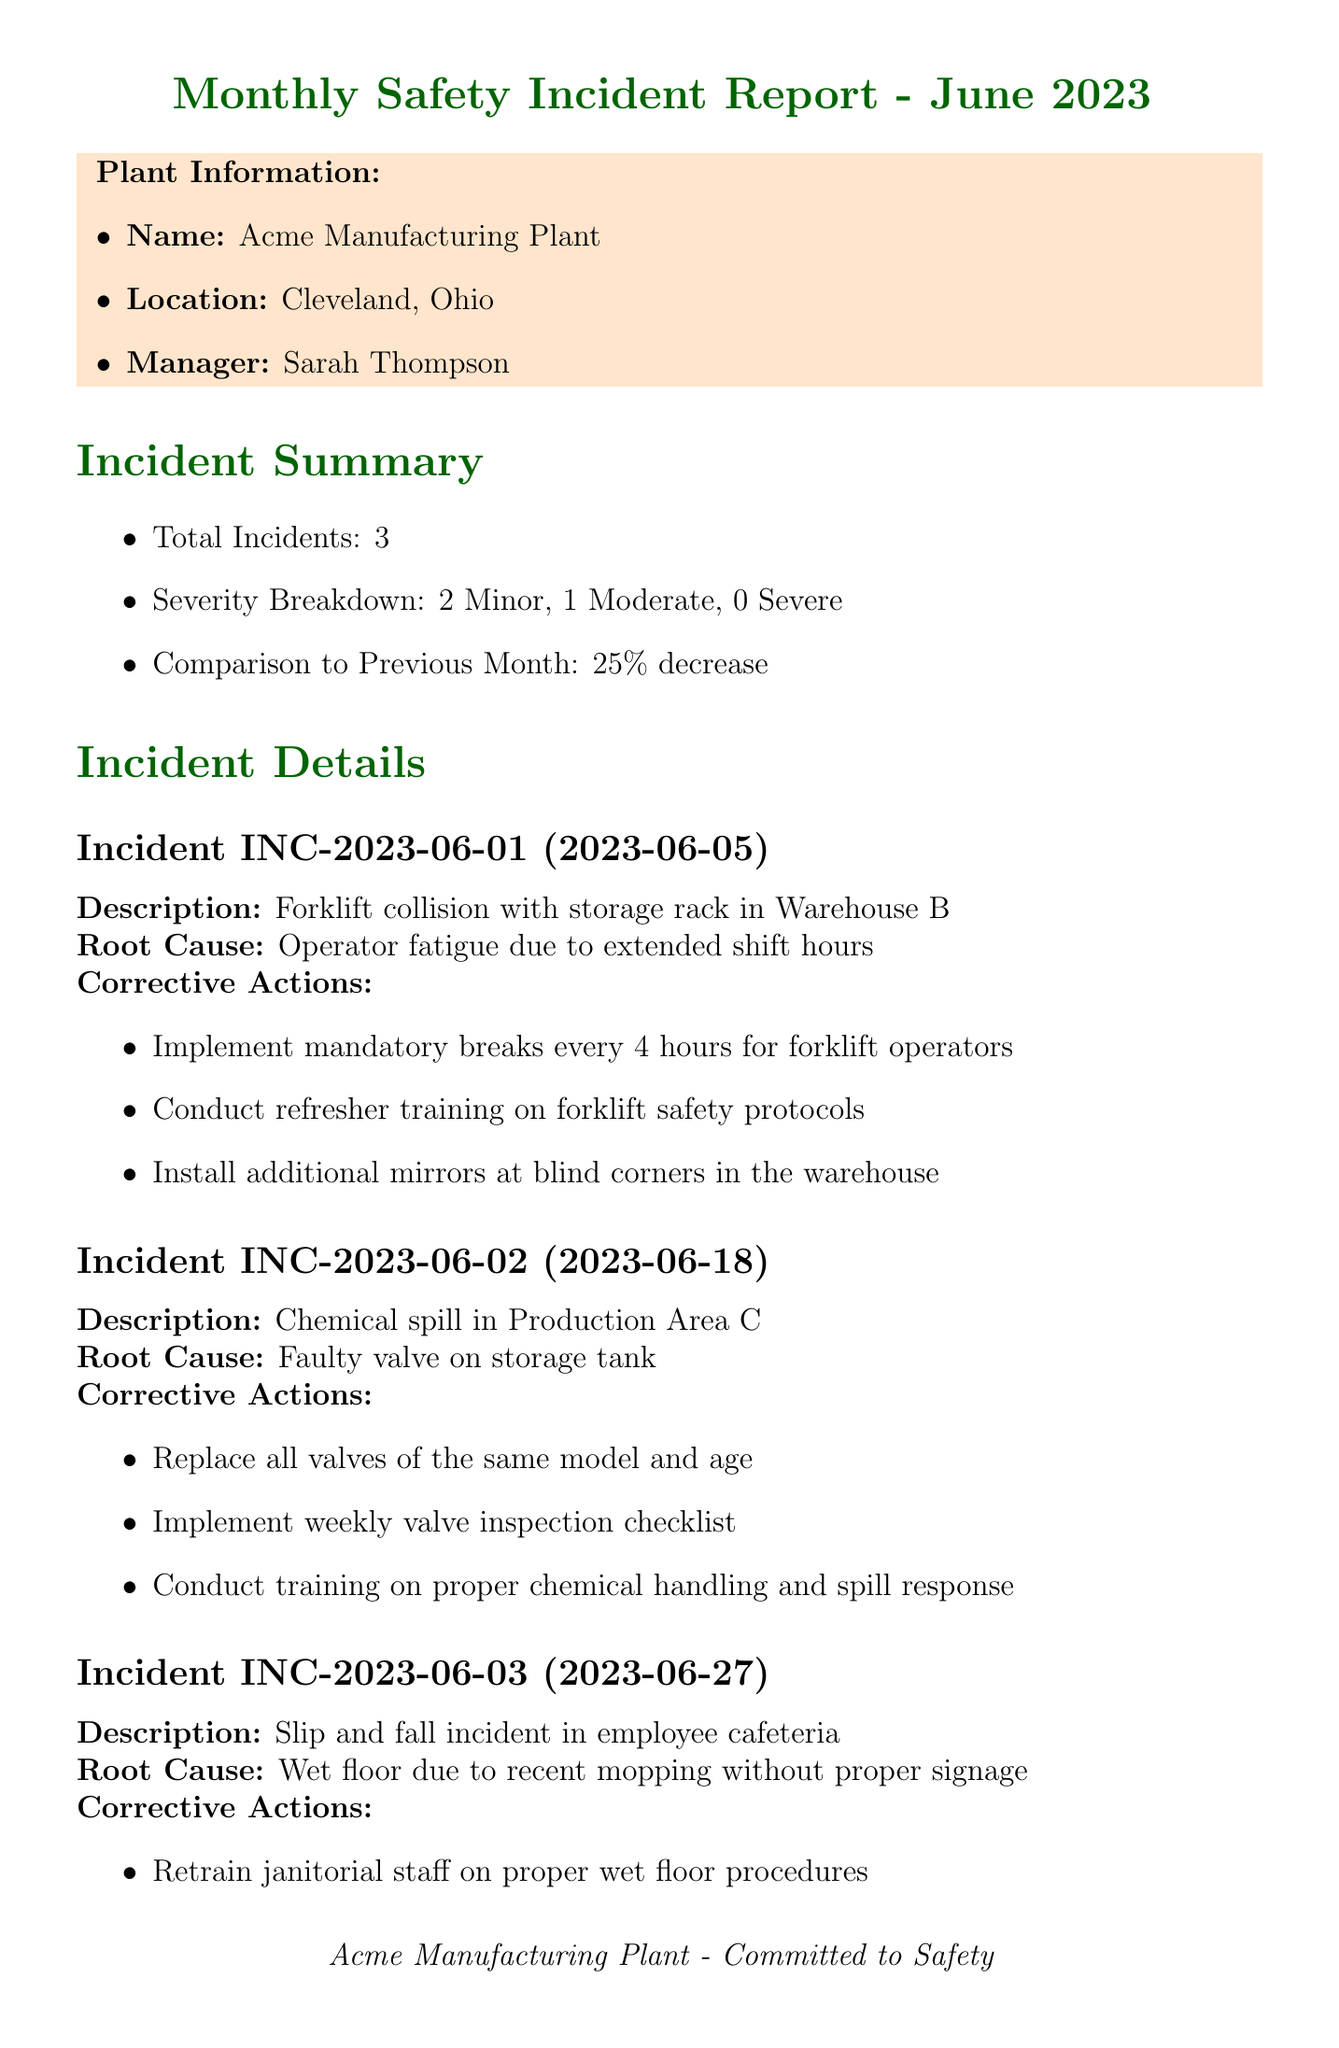What is the total number of incidents reported in June 2023? The total number of incidents in June 2023 is specified in the incident summary section of the document.
Answer: 3 What was the date of the forklift collision incident? The date of the forklift collision incident is listed under the incident details for that specific incident.
Answer: 2023-06-05 Which area had a chemical spill incident? The location of the chemical spill incident is provided in the description of that incident.
Answer: Production Area C What is one corrective action for the slip and fall incident? One of the corrective actions for the slip and fall incident can be found in the list of actions taken in the incident details.
Answer: Retrain janitorial staff on proper wet floor procedures What is the implementation date for the PPE upgrade initiative? The implementation date for the PPE upgrade can be found in the safety initiatives section of the document.
Answer: 2023-08-15 How many minor incidents were reported in June 2023? The severity breakdown in the incident summary provides the count of minor incidents.
Answer: 2 What feedback was received from the Anonymous Suggestion Box? The feedback source and details are listed in the employee feedback section.
Answer: Request for more frequent safety drills What is one of the focus areas mentioned in the conclusion? Focus areas are listed in the conclusion section of the document, which summarizes key improvement areas.
Answer: Continued emphasis on proper equipment maintenance What is the title of the report? The title of the report is presented at the top of the document.
Answer: Monthly Safety Incident Report - June 2023 